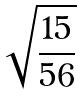<formula> <loc_0><loc_0><loc_500><loc_500>\sqrt { \frac { 1 5 } { 5 6 } }</formula> 